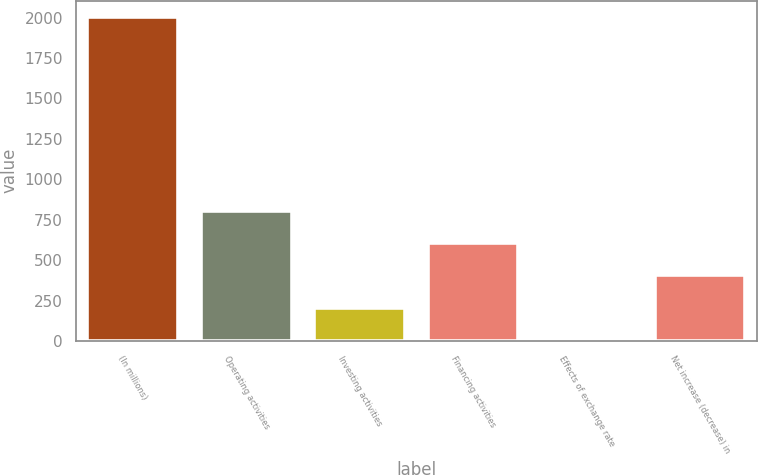Convert chart. <chart><loc_0><loc_0><loc_500><loc_500><bar_chart><fcel>(In millions)<fcel>Operating activities<fcel>Investing activities<fcel>Financing activities<fcel>Effects of exchange rate<fcel>Net increase (decrease) in<nl><fcel>2006<fcel>805.4<fcel>205.1<fcel>605.3<fcel>5<fcel>405.2<nl></chart> 